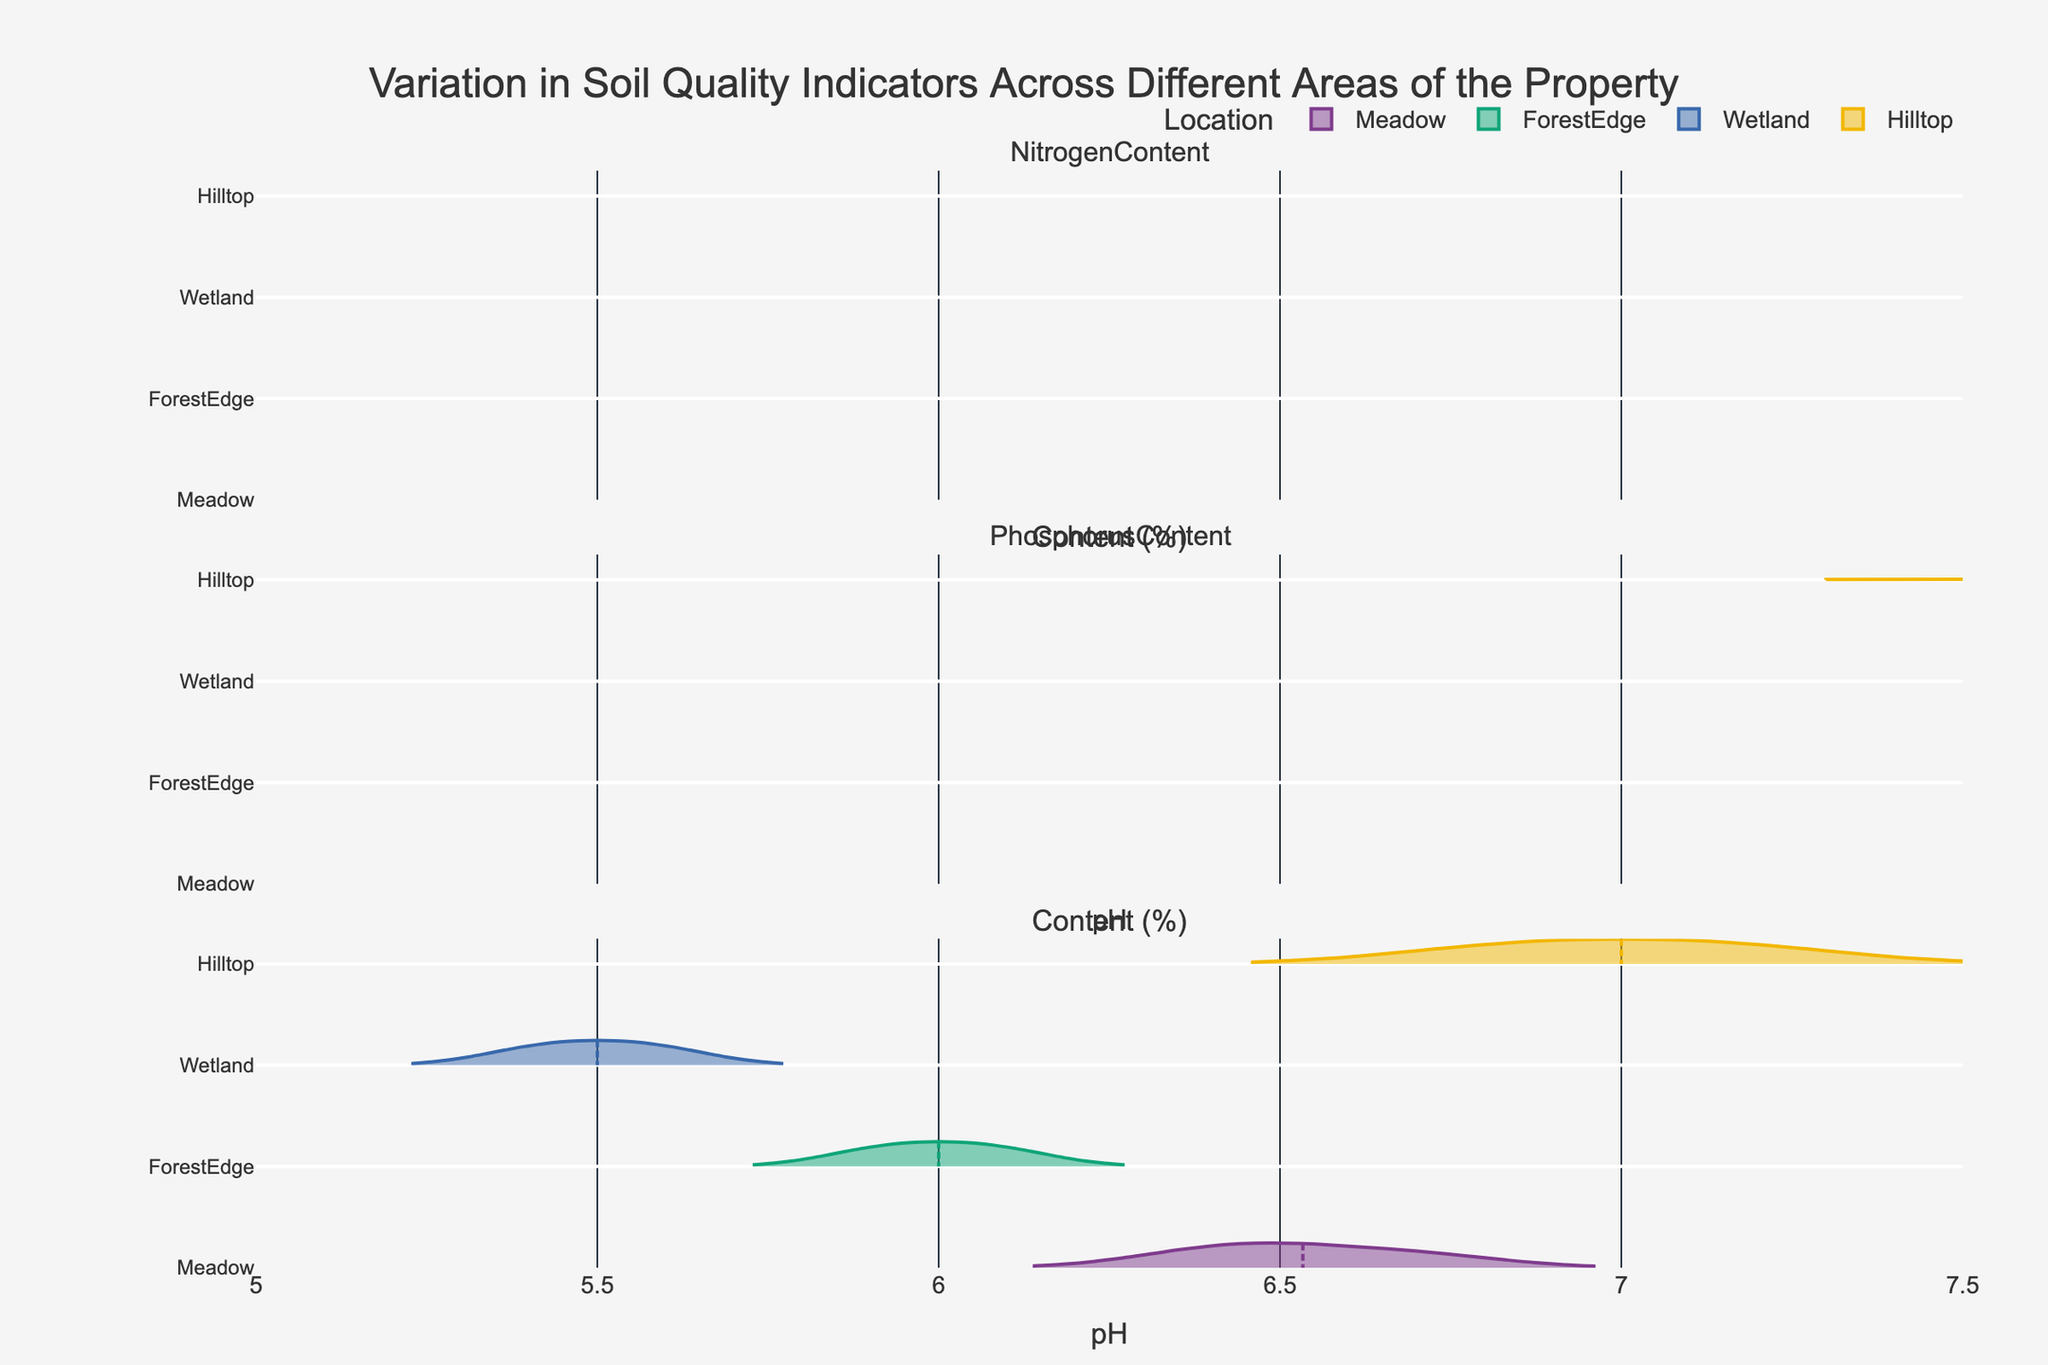How many soil quality indicators are shown in the figure? The figure has subplots for each soil quality indicator. Each subplot title indicates a different indicator. By counting the subplot titles, we can determine the number of indicators.
Answer: 3 Which location has the highest median phosphorus content? By looking at the violin plots for phosphorus content across different locations, we identify the location with the violin plot centered around the highest median value.
Answer: Wetland What is the range of pH values for the Meadow location? For the Meadow location in the pH subplot, we observe the spread of the violin plot, which gives us the minimum and maximum values.
Answer: 6.4 to 6.7 Which location has the lowest average nitrogen content? We compare the violin plots for nitrogen content across all locations and determine the one centered around the lowest average value.
Answer: Hilltop For which soil quality indicator is the Hilltop location most distinct from the others? We compare the distribution of values in the Hilltop violin plots across all indicators and see where Hilltop is most different from the others.
Answer: Phosphorus Content Is the nitrogen content more variable in the Wetland or ForestEdge location? We compare the width and shape of the violin plots for nitrogen content in both Wetland and ForestEdge to see which one shows more variability.
Answer: Wetland What does the meanline in the violin plots represent? The meanline visible in each violin plot represents the average value of the data points for that particular location and soil quality indicator.
Answer: Average value Which location shows a higher maximum nitrogen content, Meadow or ForestEdge? We look at the rightmost values on the violin plots for nitrogen content in both Meadow and ForestEdge and compare them.
Answer: ForestEdge How does the variability in pH levels compare between the Wetland and Hilltop locations? By observing the height and spread of the violin plots for pH levels, we can compare the variability.
Answer: Hilltop has less variability 